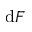<formula> <loc_0><loc_0><loc_500><loc_500>d F</formula> 